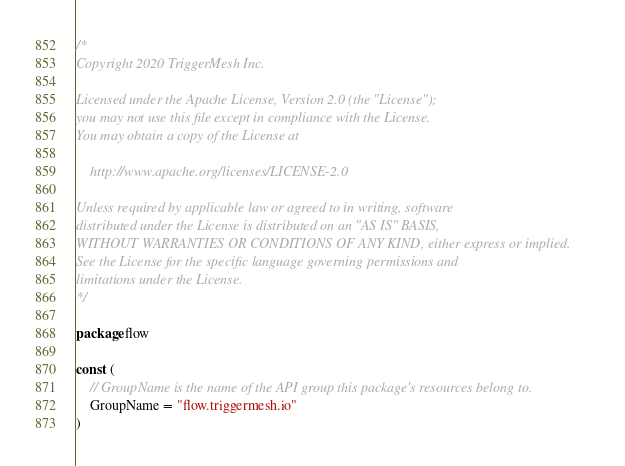<code> <loc_0><loc_0><loc_500><loc_500><_Go_>/*
Copyright 2020 TriggerMesh Inc.

Licensed under the Apache License, Version 2.0 (the "License");
you may not use this file except in compliance with the License.
You may obtain a copy of the License at

    http://www.apache.org/licenses/LICENSE-2.0

Unless required by applicable law or agreed to in writing, software
distributed under the License is distributed on an "AS IS" BASIS,
WITHOUT WARRANTIES OR CONDITIONS OF ANY KIND, either express or implied.
See the License for the specific language governing permissions and
limitations under the License.
*/

package flow

const (
	// GroupName is the name of the API group this package's resources belong to.
	GroupName = "flow.triggermesh.io"
)
</code> 